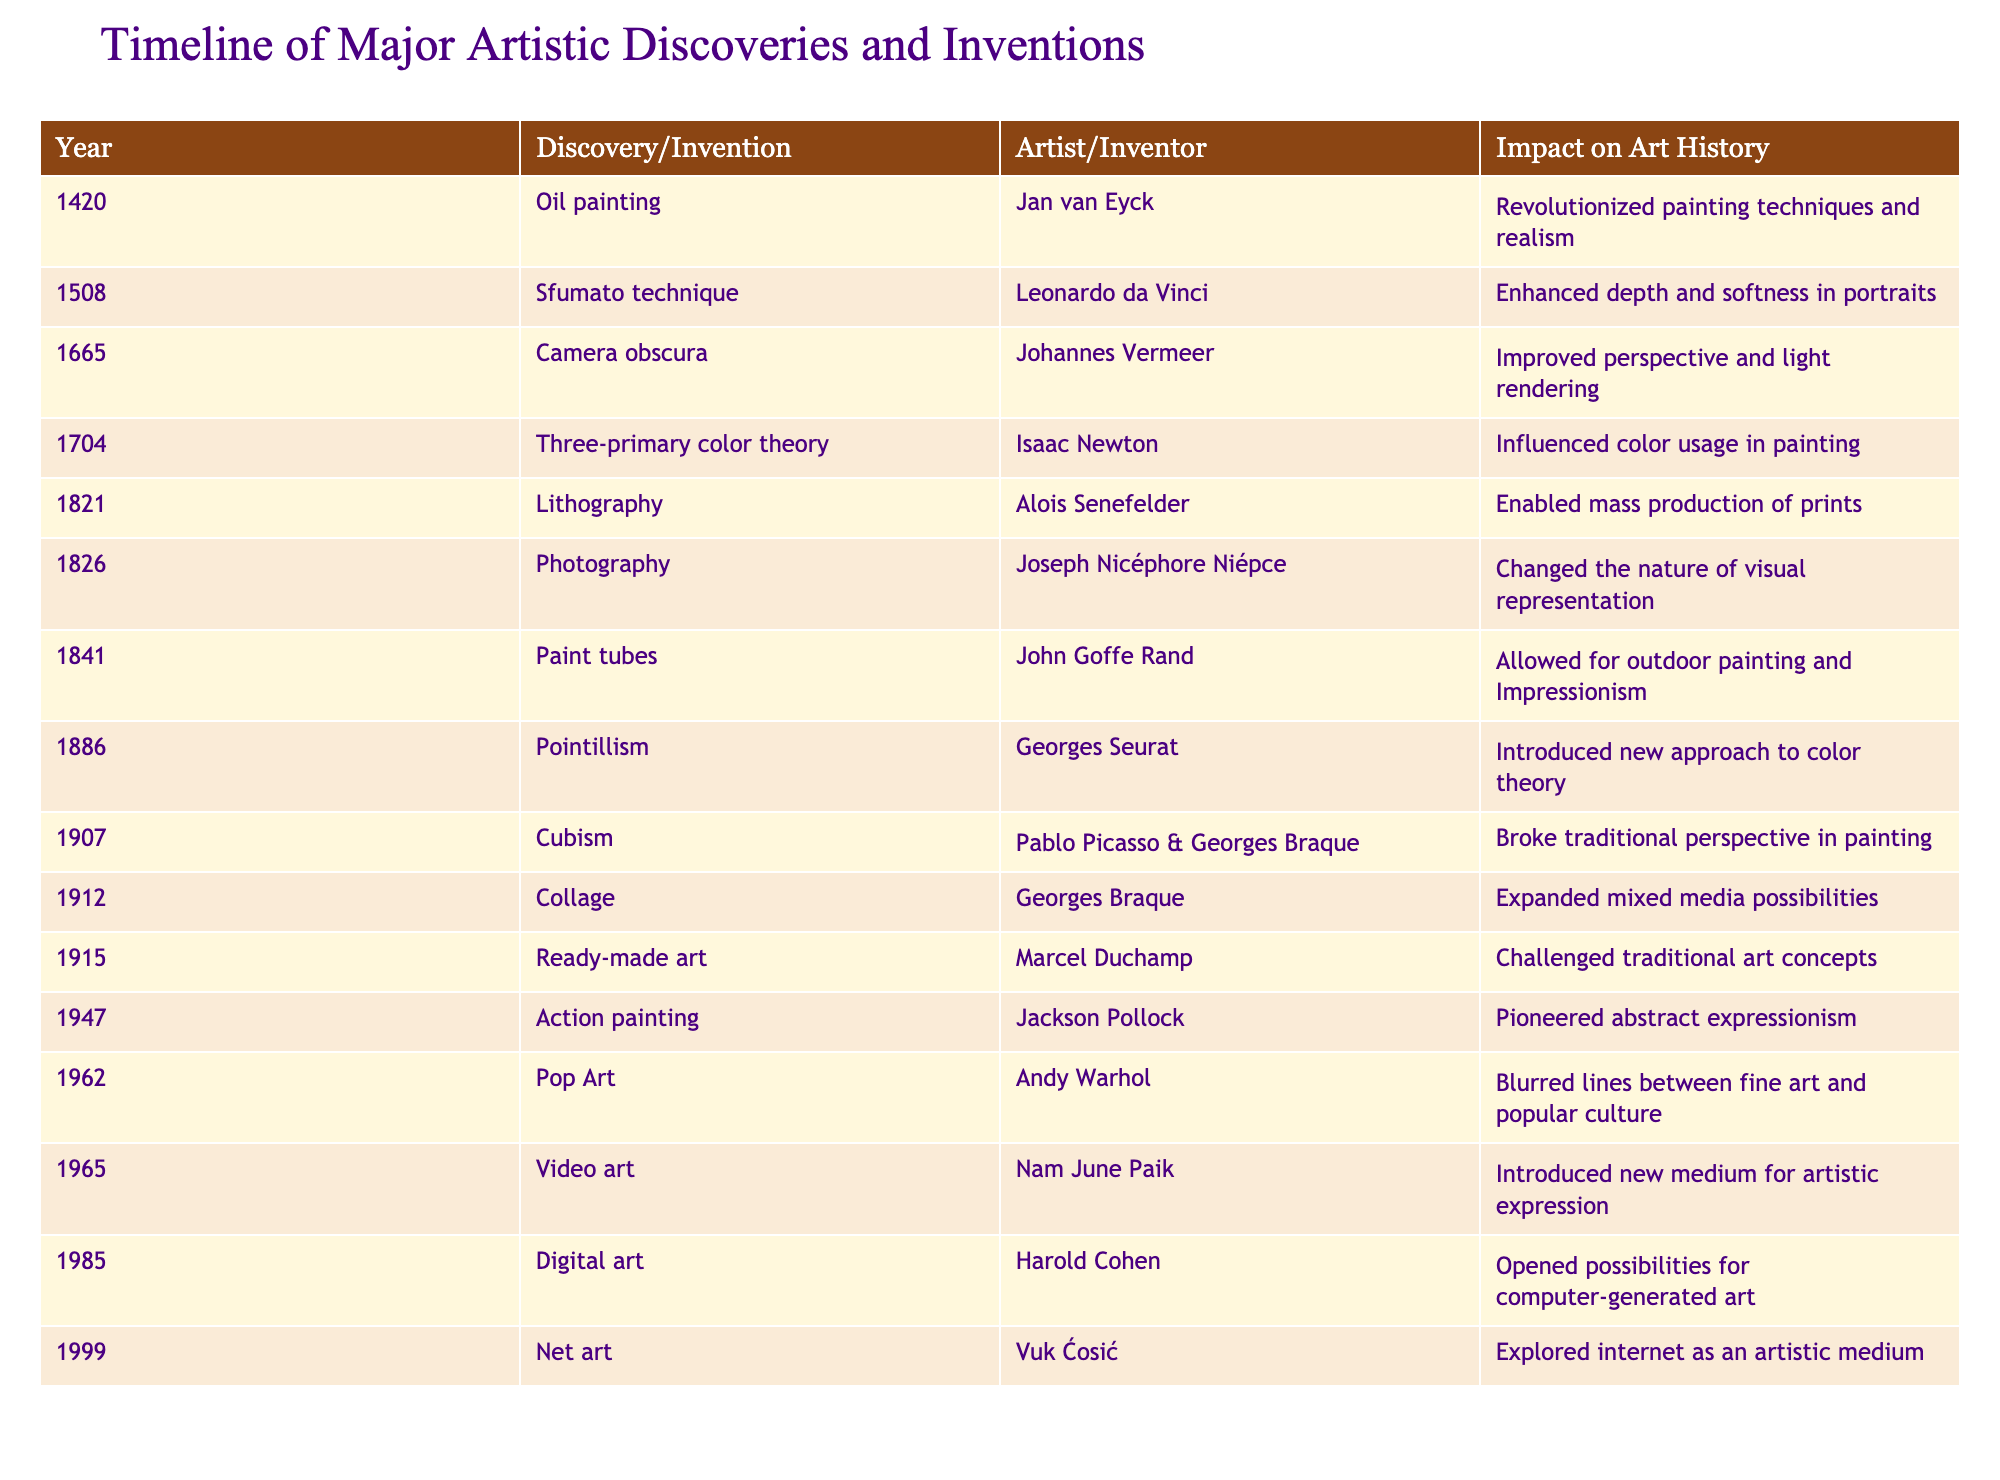What year was photography invented? The invention of photography is listed in the table under the year 1826 beside Joseph Nicéphore Niépce.
Answer: 1826 Who created the sfumato technique? The table shows that the sfumato technique was developed by Leonardo da Vinci in the year 1508.
Answer: Leonardo da Vinci Which invention allowed for outdoor painting? According to the table, the invention that allowed for outdoor painting is the paint tubes, developed by John Goffe Rand in 1841.
Answer: Paint tubes How many years after the invention of oil painting was the creation of the ready-made art? Oil painting was invented in 1420 and ready-made art was introduced in 1915. The difference in years is 1915 - 1420 = 495 years.
Answer: 495 years Was Action painting developed before Cubism? The table lists Action painting in 1947 and Cubism in 1907, confirming that Cubism was developed first.
Answer: Yes Which discovery had the greatest impact on color theory? The table indicates that Pointillism, introduced by Georges Seurat in 1886, is a significant discovery in color theory, and it directly states that it introduced a new approach to color theory.
Answer: Pointillism How many artistic discoveries were made before the 20th century? By looking at the years listed in the table, there are 10 discoveries before 1900 (up to 1899).
Answer: 10 Was Net art invented after Digital art? The table places Digital art in 1985 and Net art in 1999, confirming that Net art was invented afterward.
Answer: Yes What was a major impact of photography on art history? The table specifies that the invention of photography changed the nature of visual representation, which is a significant impact on art history.
Answer: Changed visual representation Which two inventions are associated with Georges Braque? According to the table, Georges Braque is associated with both Cubism in 1907 and Collage in 1912.
Answer: Cubism and Collage 